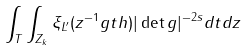<formula> <loc_0><loc_0><loc_500><loc_500>\int _ { T } \int _ { Z _ { k } } \xi _ { L ^ { \prime } } ( z ^ { - 1 } g t h ) | \det g | ^ { - 2 s } d t d z</formula> 